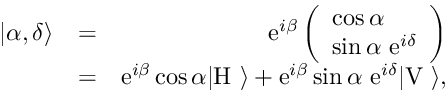<formula> <loc_0><loc_0><loc_500><loc_500>\begin{array} { r l r } { | \alpha , \delta \rangle } & { = } & { e ^ { i \beta } \left ( \begin{array} { c } { \cos \alpha \quad } \\ { \sin \alpha \ e ^ { i \delta } } \end{array} \right ) } \\ & { = } & { e ^ { i \beta } \cos \alpha | H \ \rangle + e ^ { i \beta } \sin \alpha \ e ^ { i \delta } | V \ \rangle , } \end{array}</formula> 